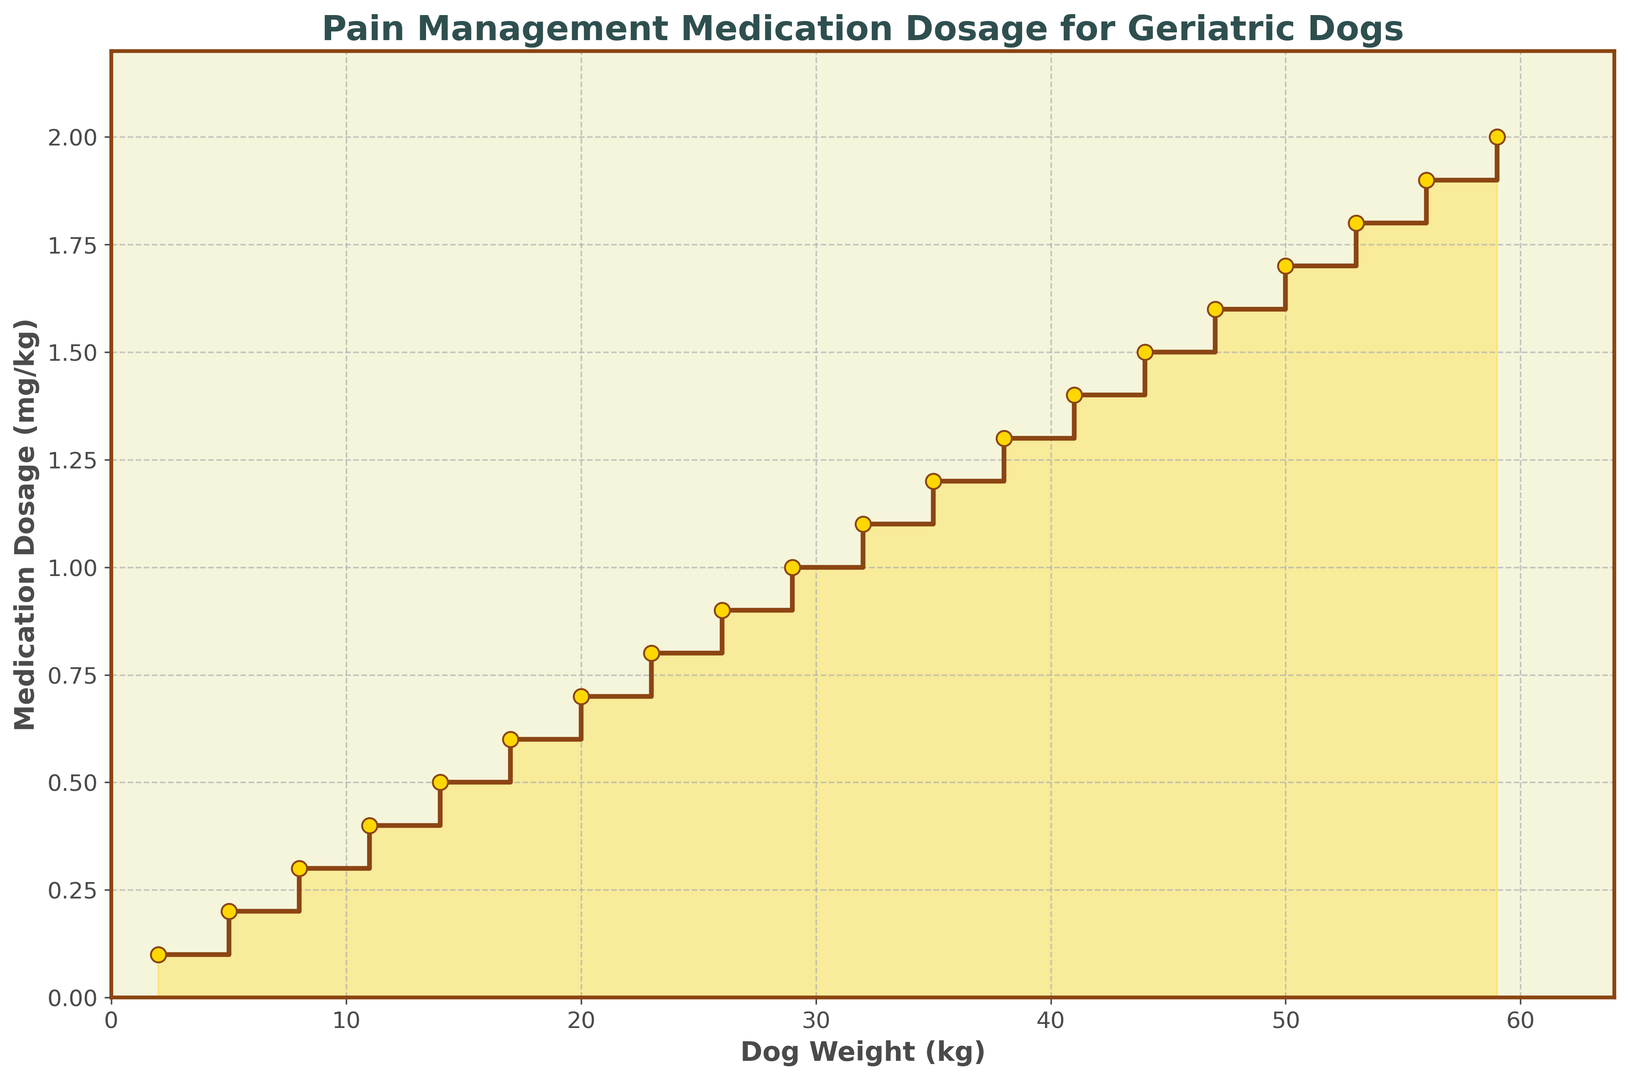What is the medication dosage for a 20 kg dog? To determine this, locate the weight value on the x-axis (20 kg). Move vertically to the corresponding point on the stairs plot, which shows a dosage of 0.7 mg/kg.
Answer: 0.7 mg/kg How does the medication dosage change from a dog weighing 14 kg to one weighing 17 kg? Identify the dosages for 14 kg and 17 kg on the y-axis. The dosage for 14 kg is 0.5 mg/kg, and for 17 kg, it is 0.6 mg/kg. The increase is 0.6 - 0.5 = 0.1 mg/kg.
Answer: Increases by 0.1 mg/kg Is the medication dosage higher for a dog weighing 44 kg or 41 kg? Compare the dosages for 44 kg (1.5 mg/kg) and 41 kg (1.4 mg/kg) on the y-axis. The dosage for 44 kg is higher.
Answer: 44 kg What is the total increase in medication dosage from a dog weighing 2 kg to one weighing 29 kg? Identify the dosages for 2 kg (0.1 mg/kg) and 29 kg (1.0 mg/kg). Calculate the difference: 1.0 - 0.1 = 0.9 mg/kg.
Answer: 0.9 mg/kg At which dog weight does the medication dosage first reach 1.0 mg/kg? Locate the point where the dosage reaches 1.0 mg/kg on the y-axis. The corresponding weight on the x-axis is 29 kg.
Answer: 29 kg Is the rate of increase in medication dosage per kg constant across all weights? Examine the steps between each weight category on the plot. The dosage increases by 0.1 mg/kg for every 3 kg increment, indicating a constant rate of increase.
Answer: Yes For a dog weight of 50 kg, what is the dosage and how does it compare to the dosage for a 47 kg dog? Find the dosages for 50 kg (1.7 mg/kg) and 47 kg (1.6 mg/kg). The dosage for 50 kg is higher by 0.1 mg/kg.
Answer: 1.7 mg/kg, higher by 0.1 mg/kg If a dog’s weight increases from 23 kg to 26 kg, by how much does the medication dosage increase? Identify the dosages for 23 kg (0.8 mg/kg) and 26 kg (0.9 mg/kg). The increase is 0.9 - 0.8 = 0.1 mg/kg.
Answer: 0.1 mg/kg What is the average medication dosage for dogs weighing between 35 kg and 41 kg? Find the dosages for 35 kg (1.2 mg/kg) and 41 kg (1.4 mg/kg), then average them: (1.2 + 1.3 + 1.4) / 3 = 1.3 mg/kg.
Answer: 1.3 mg/kg What visual feature indicates the step pattern in the medication dosage? The plot uses horizontal lines with markers at each dog weight, creating a step pattern where each step represents a specific dosage level. The lines connecting the steps indicate the increase in dosage.
Answer: Horizontal lines with markers 